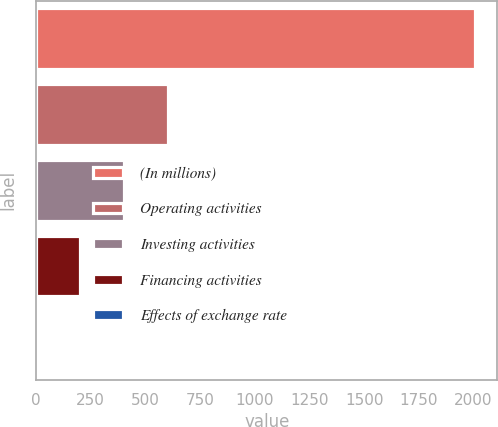Convert chart to OTSL. <chart><loc_0><loc_0><loc_500><loc_500><bar_chart><fcel>(In millions)<fcel>Operating activities<fcel>Investing activities<fcel>Financing activities<fcel>Effects of exchange rate<nl><fcel>2009<fcel>603.4<fcel>402.6<fcel>201.8<fcel>1<nl></chart> 